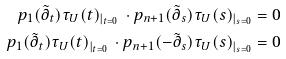<formula> <loc_0><loc_0><loc_500><loc_500>p _ { 1 } ( \tilde { \partial } _ { t } ) \tau _ { U } ( t ) _ { | _ { t = 0 } } \, \cdot p _ { n + 1 } ( \tilde { \partial } _ { s } ) \tau _ { U } ( s ) _ { | _ { s = 0 } } & = 0 \\ p _ { 1 } ( \tilde { \partial } _ { t } ) \tau _ { U } ( t ) _ { | _ { t = 0 } } \, \cdot p _ { n + 1 } ( - \tilde { \partial } _ { s } ) \tau _ { U } ( s ) _ { | _ { s = 0 } } & = 0</formula> 